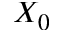<formula> <loc_0><loc_0><loc_500><loc_500>X _ { 0 }</formula> 